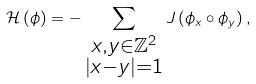Convert formula to latex. <formula><loc_0><loc_0><loc_500><loc_500>\mathcal { H } \left ( \phi \right ) = - \sum _ { \substack { x , y \in \mathbb { Z } ^ { 2 } \\ \left | x - y \right | = 1 } } J \left ( \phi _ { x } \circ \phi _ { y } \right ) ,</formula> 